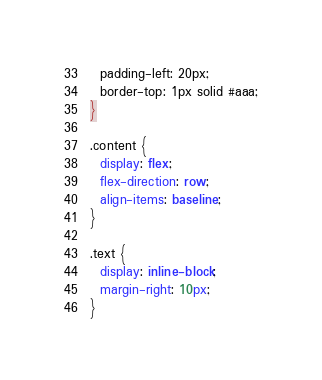<code> <loc_0><loc_0><loc_500><loc_500><_CSS_>  padding-left: 20px;
  border-top: 1px solid #aaa;
}

.content {
  display: flex;
  flex-direction: row;
  align-items: baseline;
}

.text {
  display: inline-block;
  margin-right: 10px;
}
</code> 